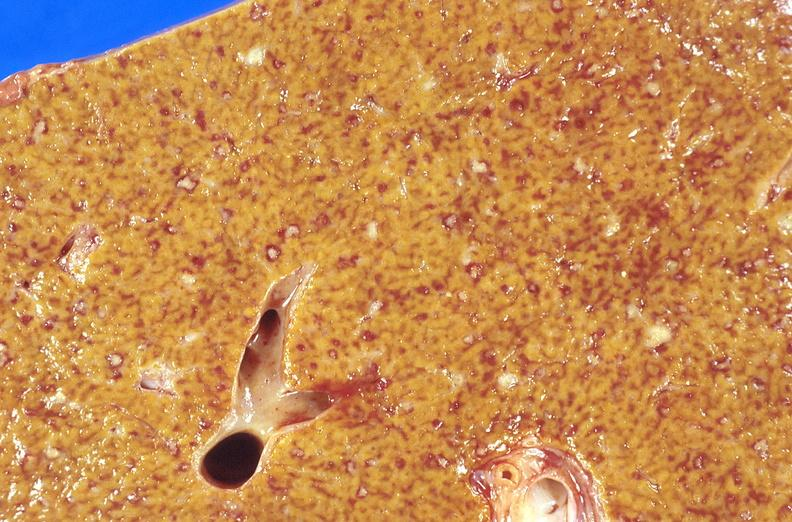what is present?
Answer the question using a single word or phrase. Hepatobiliary 